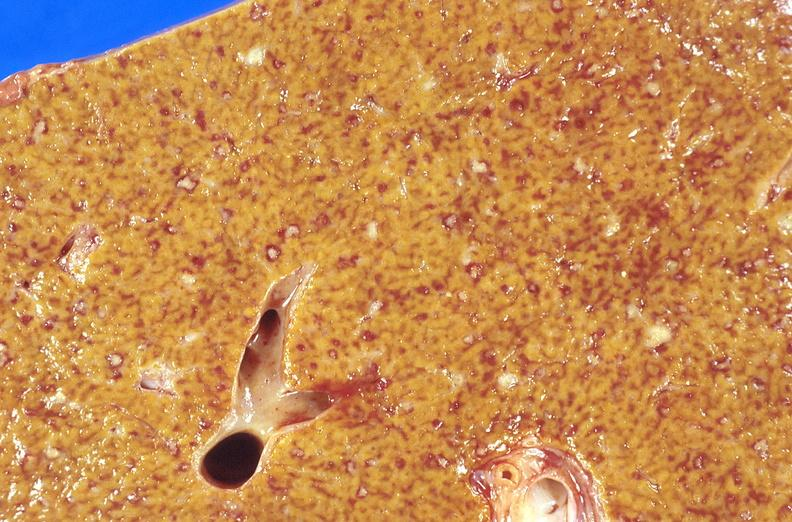what is present?
Answer the question using a single word or phrase. Hepatobiliary 